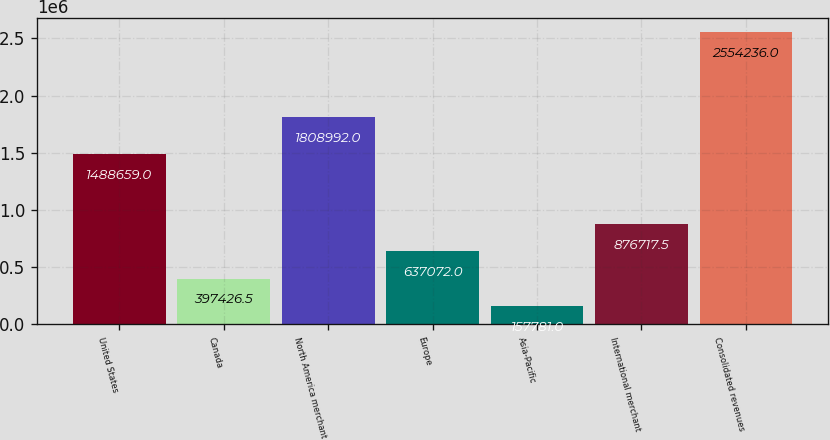Convert chart to OTSL. <chart><loc_0><loc_0><loc_500><loc_500><bar_chart><fcel>United States<fcel>Canada<fcel>North America merchant<fcel>Europe<fcel>Asia-Pacific<fcel>International merchant<fcel>Consolidated revenues<nl><fcel>1.48866e+06<fcel>397426<fcel>1.80899e+06<fcel>637072<fcel>157781<fcel>876718<fcel>2.55424e+06<nl></chart> 